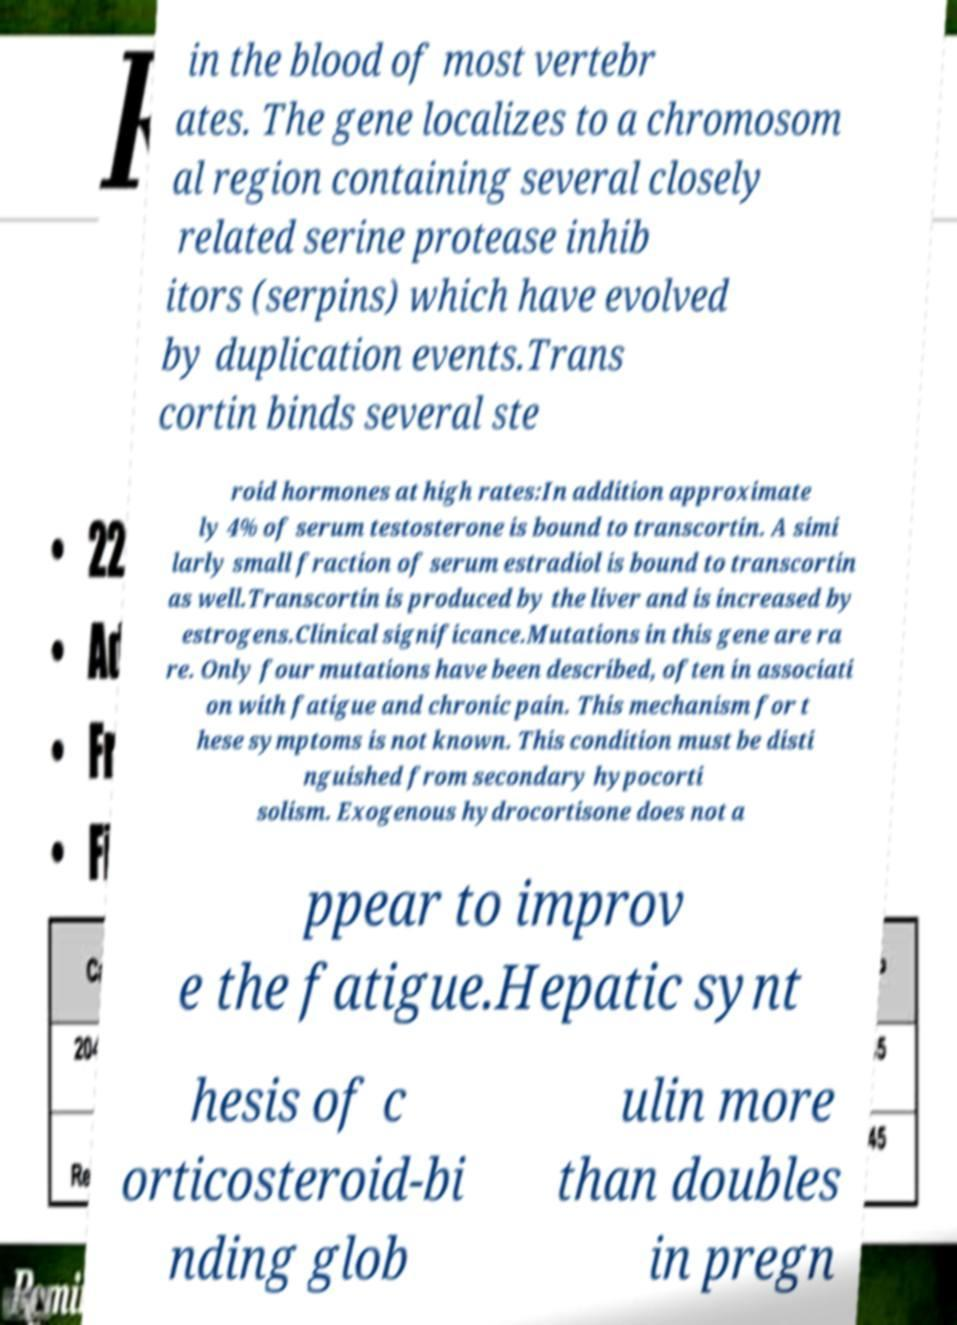There's text embedded in this image that I need extracted. Can you transcribe it verbatim? in the blood of most vertebr ates. The gene localizes to a chromosom al region containing several closely related serine protease inhib itors (serpins) which have evolved by duplication events.Trans cortin binds several ste roid hormones at high rates:In addition approximate ly 4% of serum testosterone is bound to transcortin. A simi larly small fraction of serum estradiol is bound to transcortin as well.Transcortin is produced by the liver and is increased by estrogens.Clinical significance.Mutations in this gene are ra re. Only four mutations have been described, often in associati on with fatigue and chronic pain. This mechanism for t hese symptoms is not known. This condition must be disti nguished from secondary hypocorti solism. Exogenous hydrocortisone does not a ppear to improv e the fatigue.Hepatic synt hesis of c orticosteroid-bi nding glob ulin more than doubles in pregn 